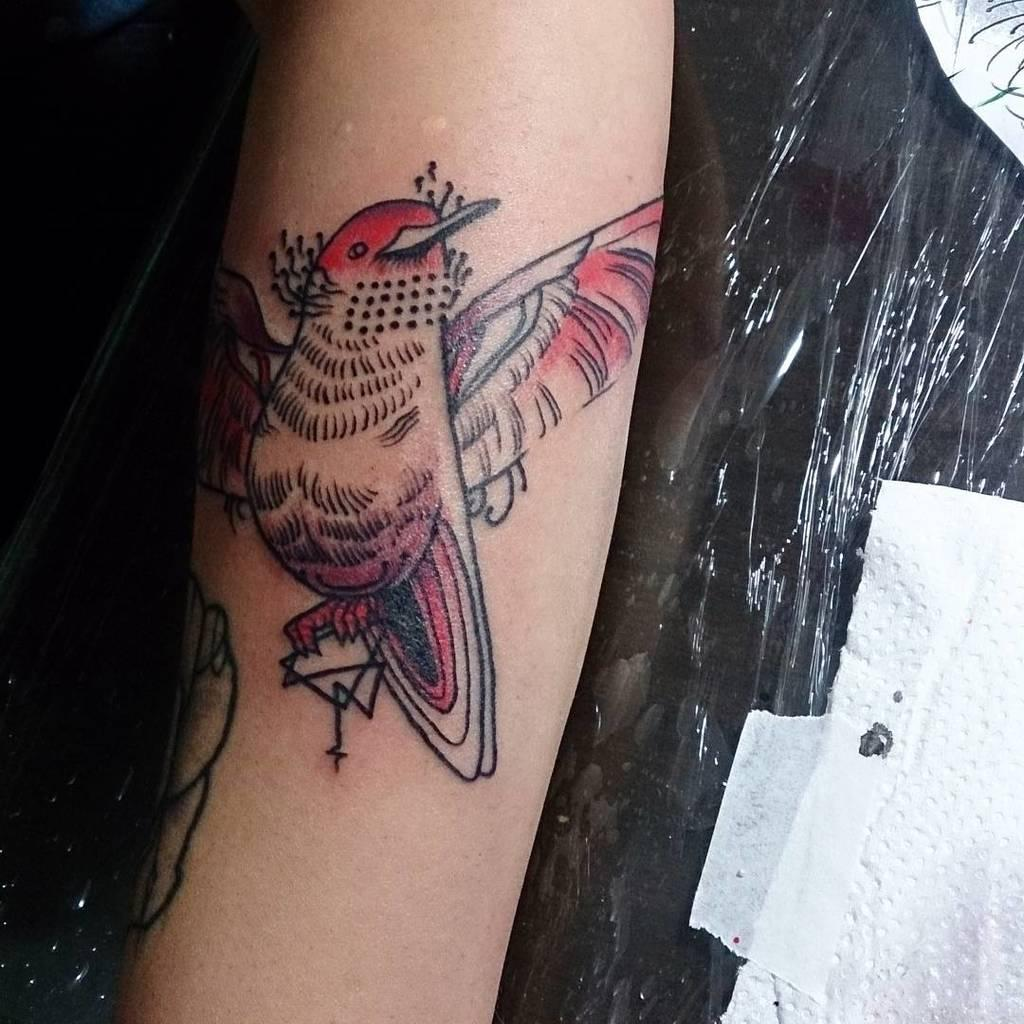What is present in the image? There is a person in the image. Can you describe any distinguishing features of the person? The person has a tattoo on their hand. What else can be seen under the person's hand? There is a black color cover visible under the person's hand. What country is the person from in the image? The country of origin of the person cannot be determined from the image. How tightly is the person gripping the black color cover in the image? The image does not provide information about the person's grip on the black color cover. 